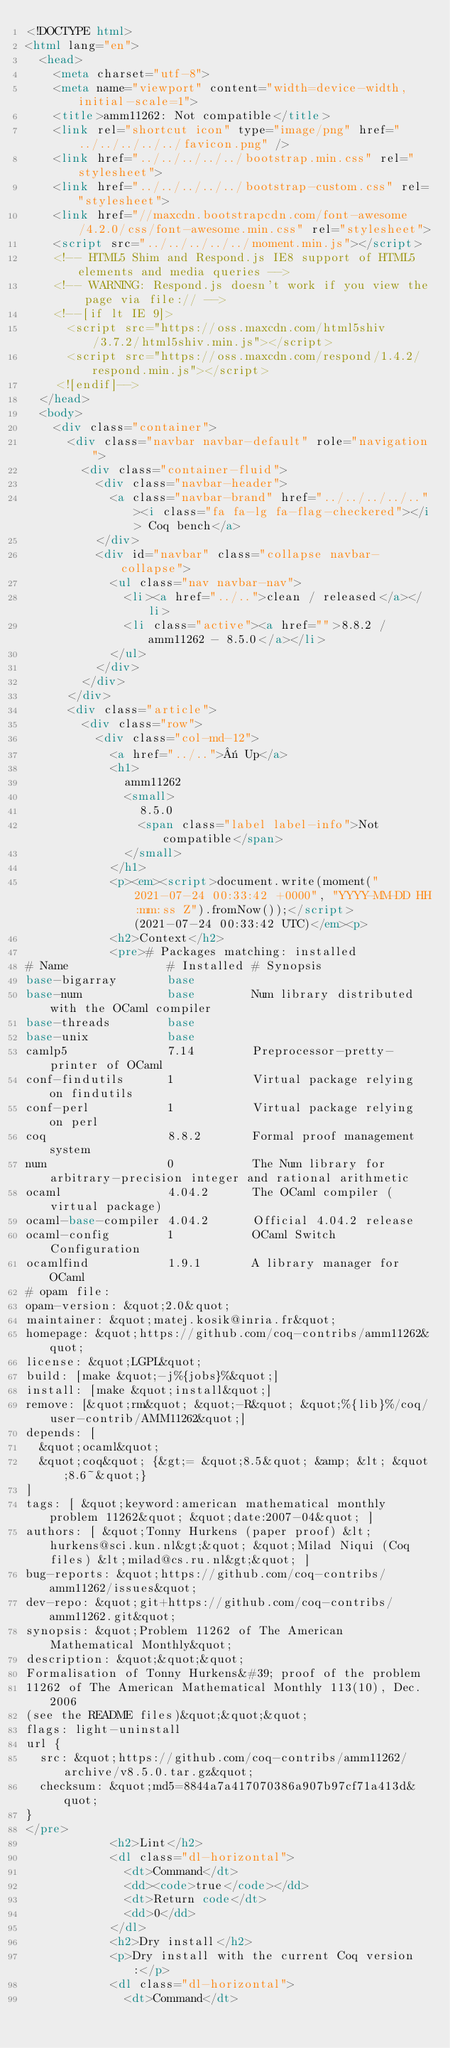Convert code to text. <code><loc_0><loc_0><loc_500><loc_500><_HTML_><!DOCTYPE html>
<html lang="en">
  <head>
    <meta charset="utf-8">
    <meta name="viewport" content="width=device-width, initial-scale=1">
    <title>amm11262: Not compatible</title>
    <link rel="shortcut icon" type="image/png" href="../../../../../favicon.png" />
    <link href="../../../../../bootstrap.min.css" rel="stylesheet">
    <link href="../../../../../bootstrap-custom.css" rel="stylesheet">
    <link href="//maxcdn.bootstrapcdn.com/font-awesome/4.2.0/css/font-awesome.min.css" rel="stylesheet">
    <script src="../../../../../moment.min.js"></script>
    <!-- HTML5 Shim and Respond.js IE8 support of HTML5 elements and media queries -->
    <!-- WARNING: Respond.js doesn't work if you view the page via file:// -->
    <!--[if lt IE 9]>
      <script src="https://oss.maxcdn.com/html5shiv/3.7.2/html5shiv.min.js"></script>
      <script src="https://oss.maxcdn.com/respond/1.4.2/respond.min.js"></script>
    <![endif]-->
  </head>
  <body>
    <div class="container">
      <div class="navbar navbar-default" role="navigation">
        <div class="container-fluid">
          <div class="navbar-header">
            <a class="navbar-brand" href="../../../../.."><i class="fa fa-lg fa-flag-checkered"></i> Coq bench</a>
          </div>
          <div id="navbar" class="collapse navbar-collapse">
            <ul class="nav navbar-nav">
              <li><a href="../..">clean / released</a></li>
              <li class="active"><a href="">8.8.2 / amm11262 - 8.5.0</a></li>
            </ul>
          </div>
        </div>
      </div>
      <div class="article">
        <div class="row">
          <div class="col-md-12">
            <a href="../..">« Up</a>
            <h1>
              amm11262
              <small>
                8.5.0
                <span class="label label-info">Not compatible</span>
              </small>
            </h1>
            <p><em><script>document.write(moment("2021-07-24 00:33:42 +0000", "YYYY-MM-DD HH:mm:ss Z").fromNow());</script> (2021-07-24 00:33:42 UTC)</em><p>
            <h2>Context</h2>
            <pre># Packages matching: installed
# Name              # Installed # Synopsis
base-bigarray       base
base-num            base        Num library distributed with the OCaml compiler
base-threads        base
base-unix           base
camlp5              7.14        Preprocessor-pretty-printer of OCaml
conf-findutils      1           Virtual package relying on findutils
conf-perl           1           Virtual package relying on perl
coq                 8.8.2       Formal proof management system
num                 0           The Num library for arbitrary-precision integer and rational arithmetic
ocaml               4.04.2      The OCaml compiler (virtual package)
ocaml-base-compiler 4.04.2      Official 4.04.2 release
ocaml-config        1           OCaml Switch Configuration
ocamlfind           1.9.1       A library manager for OCaml
# opam file:
opam-version: &quot;2.0&quot;
maintainer: &quot;matej.kosik@inria.fr&quot;
homepage: &quot;https://github.com/coq-contribs/amm11262&quot;
license: &quot;LGPL&quot;
build: [make &quot;-j%{jobs}%&quot;]
install: [make &quot;install&quot;]
remove: [&quot;rm&quot; &quot;-R&quot; &quot;%{lib}%/coq/user-contrib/AMM11262&quot;]
depends: [
  &quot;ocaml&quot;
  &quot;coq&quot; {&gt;= &quot;8.5&quot; &amp; &lt; &quot;8.6~&quot;}
]
tags: [ &quot;keyword:american mathematical monthly problem 11262&quot; &quot;date:2007-04&quot; ]
authors: [ &quot;Tonny Hurkens (paper proof) &lt;hurkens@sci.kun.nl&gt;&quot; &quot;Milad Niqui (Coq files) &lt;milad@cs.ru.nl&gt;&quot; ]
bug-reports: &quot;https://github.com/coq-contribs/amm11262/issues&quot;
dev-repo: &quot;git+https://github.com/coq-contribs/amm11262.git&quot;
synopsis: &quot;Problem 11262 of The American Mathematical Monthly&quot;
description: &quot;&quot;&quot;
Formalisation of Tonny Hurkens&#39; proof of the problem
11262 of The American Mathematical Monthly 113(10), Dec. 2006
(see the README files)&quot;&quot;&quot;
flags: light-uninstall
url {
  src: &quot;https://github.com/coq-contribs/amm11262/archive/v8.5.0.tar.gz&quot;
  checksum: &quot;md5=8844a7a417070386a907b97cf71a413d&quot;
}
</pre>
            <h2>Lint</h2>
            <dl class="dl-horizontal">
              <dt>Command</dt>
              <dd><code>true</code></dd>
              <dt>Return code</dt>
              <dd>0</dd>
            </dl>
            <h2>Dry install</h2>
            <p>Dry install with the current Coq version:</p>
            <dl class="dl-horizontal">
              <dt>Command</dt></code> 